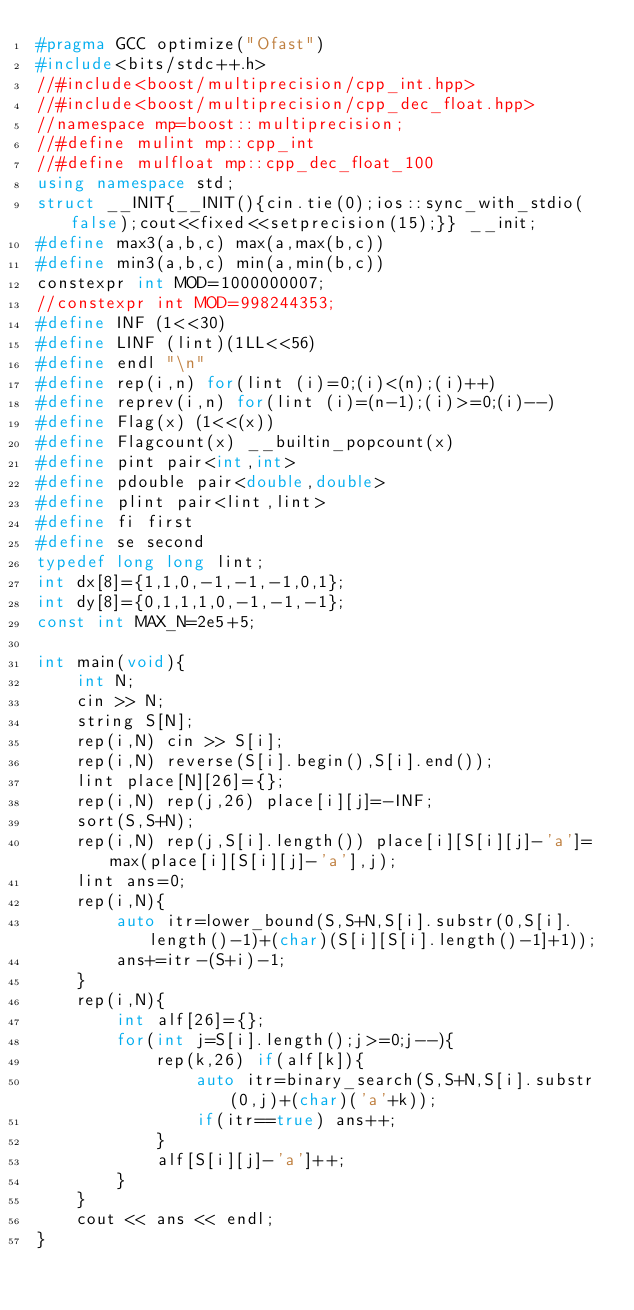Convert code to text. <code><loc_0><loc_0><loc_500><loc_500><_C++_>#pragma GCC optimize("Ofast")
#include<bits/stdc++.h>
//#include<boost/multiprecision/cpp_int.hpp>
//#include<boost/multiprecision/cpp_dec_float.hpp>
//namespace mp=boost::multiprecision;
//#define mulint mp::cpp_int
//#define mulfloat mp::cpp_dec_float_100
using namespace std;
struct __INIT{__INIT(){cin.tie(0);ios::sync_with_stdio(false);cout<<fixed<<setprecision(15);}} __init;
#define max3(a,b,c) max(a,max(b,c))
#define min3(a,b,c) min(a,min(b,c))
constexpr int MOD=1000000007;
//constexpr int MOD=998244353;
#define INF (1<<30)
#define LINF (lint)(1LL<<56)
#define endl "\n"
#define rep(i,n) for(lint (i)=0;(i)<(n);(i)++)
#define reprev(i,n) for(lint (i)=(n-1);(i)>=0;(i)--)
#define Flag(x) (1<<(x))
#define Flagcount(x) __builtin_popcount(x)
#define pint pair<int,int>
#define pdouble pair<double,double>
#define plint pair<lint,lint>
#define fi first
#define se second
typedef long long lint;
int dx[8]={1,1,0,-1,-1,-1,0,1};
int dy[8]={0,1,1,1,0,-1,-1,-1};
const int MAX_N=2e5+5;

int main(void){
    int N;
    cin >> N;
    string S[N];
    rep(i,N) cin >> S[i];
    rep(i,N) reverse(S[i].begin(),S[i].end());
    lint place[N][26]={};
    rep(i,N) rep(j,26) place[i][j]=-INF;
    sort(S,S+N);
    rep(i,N) rep(j,S[i].length()) place[i][S[i][j]-'a']=max(place[i][S[i][j]-'a'],j);
    lint ans=0;
    rep(i,N){
        auto itr=lower_bound(S,S+N,S[i].substr(0,S[i].length()-1)+(char)(S[i][S[i].length()-1]+1));
        ans+=itr-(S+i)-1;
    }
    rep(i,N){
        int alf[26]={};
        for(int j=S[i].length();j>=0;j--){
            rep(k,26) if(alf[k]){
                auto itr=binary_search(S,S+N,S[i].substr(0,j)+(char)('a'+k));
                if(itr==true) ans++;
            }
            alf[S[i][j]-'a']++;
        }
    }
    cout << ans << endl;
}</code> 